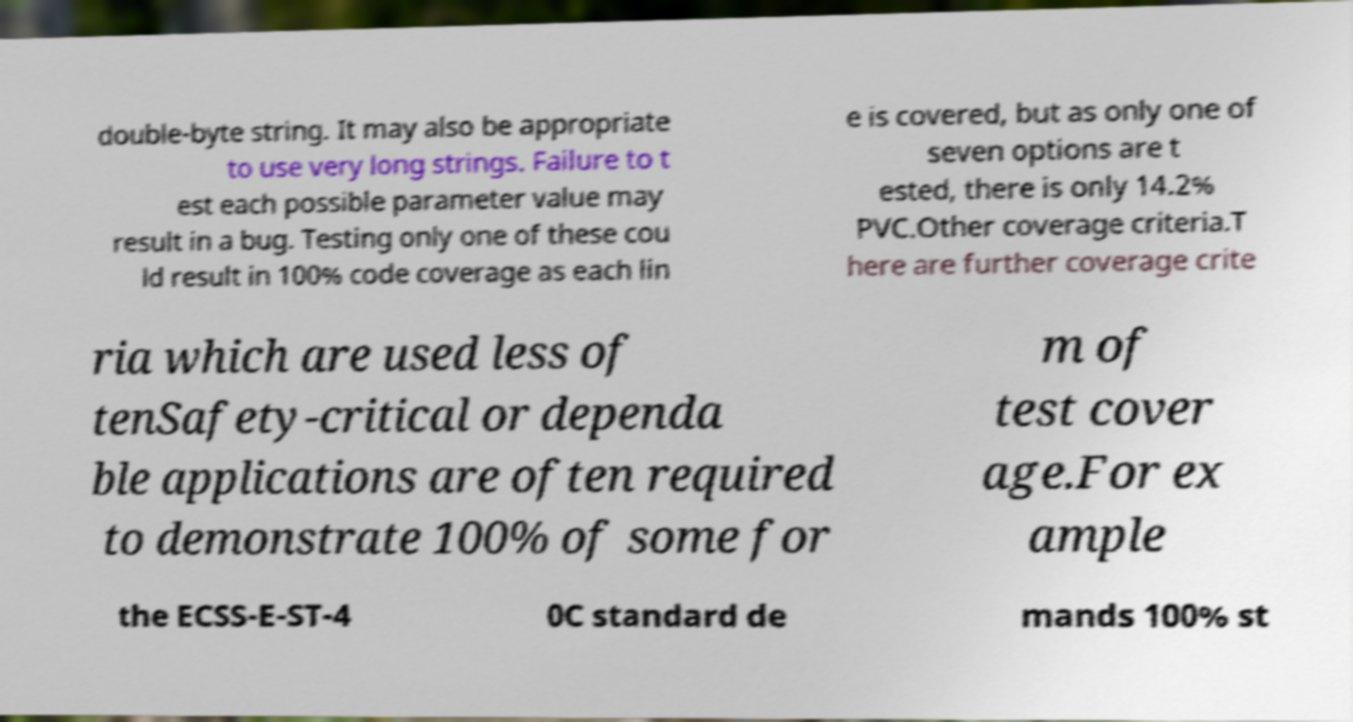Please identify and transcribe the text found in this image. double-byte string. It may also be appropriate to use very long strings. Failure to t est each possible parameter value may result in a bug. Testing only one of these cou ld result in 100% code coverage as each lin e is covered, but as only one of seven options are t ested, there is only 14.2% PVC.Other coverage criteria.T here are further coverage crite ria which are used less of tenSafety-critical or dependa ble applications are often required to demonstrate 100% of some for m of test cover age.For ex ample the ECSS-E-ST-4 0C standard de mands 100% st 